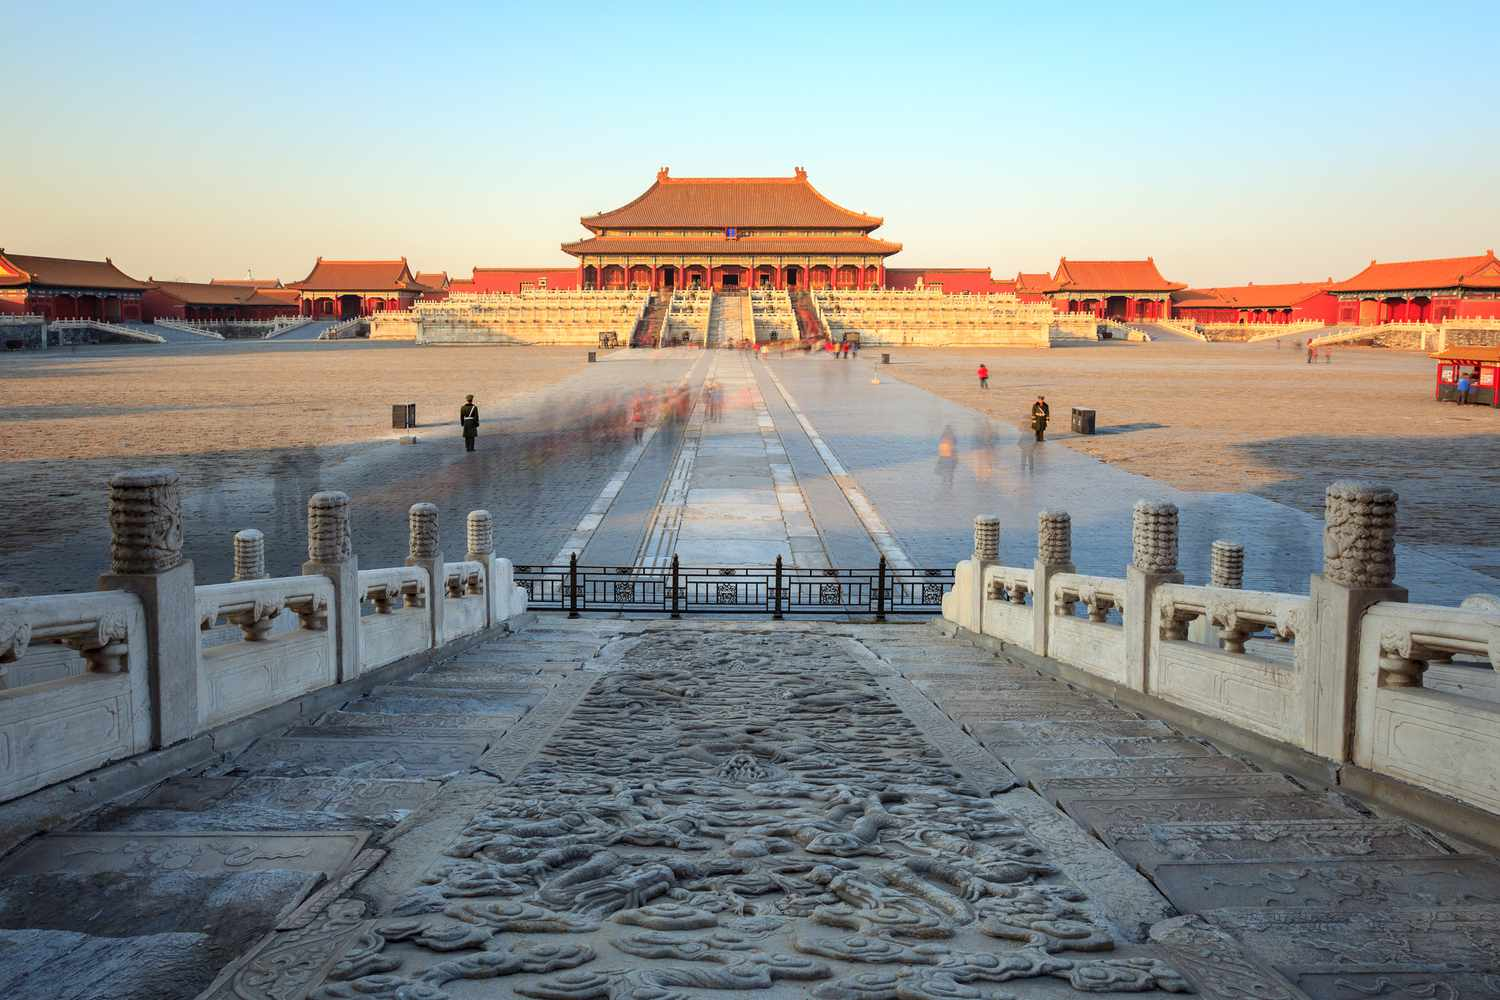What are the key elements in this picture? The photo captures the grandeur of the Forbidden City in Beijing, China, from the entrance looking towards the majestic Hall of Supreme Harmony. The bright sunlight illuminates the vibrant red walls and golden roofs of the ancient structures, creating a beautiful contrast with the gray stone ground. The entrance is prominently guarded by two stone lions, exuding an air of solemnity. A large, intricately carved stone slab lies at the center of the entrance path, drawing the eye. The courtyard is bustling with activity, with numerous people visible, their figures slightly blurred to convey movement. The image beautifully showcases the architectural brilliance and historical significance of this iconic location, highlighting its serene yet lively atmosphere. 